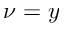Convert formula to latex. <formula><loc_0><loc_0><loc_500><loc_500>\nu = y</formula> 